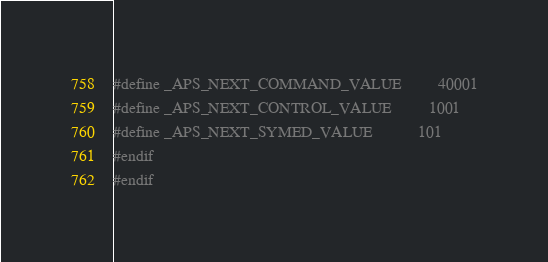Convert code to text. <code><loc_0><loc_0><loc_500><loc_500><_C_>#define _APS_NEXT_COMMAND_VALUE         40001
#define _APS_NEXT_CONTROL_VALUE         1001
#define _APS_NEXT_SYMED_VALUE           101
#endif
#endif
</code> 